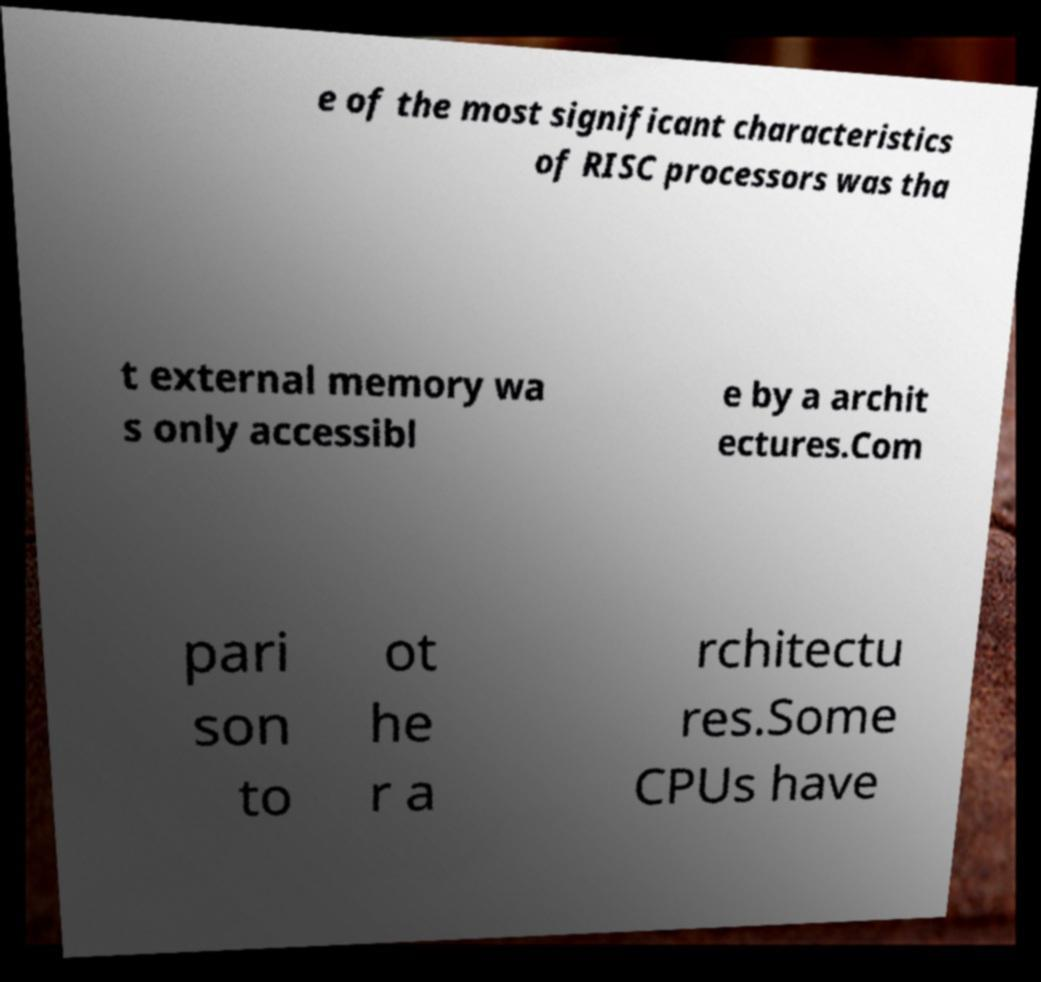For documentation purposes, I need the text within this image transcribed. Could you provide that? e of the most significant characteristics of RISC processors was tha t external memory wa s only accessibl e by a archit ectures.Com pari son to ot he r a rchitectu res.Some CPUs have 